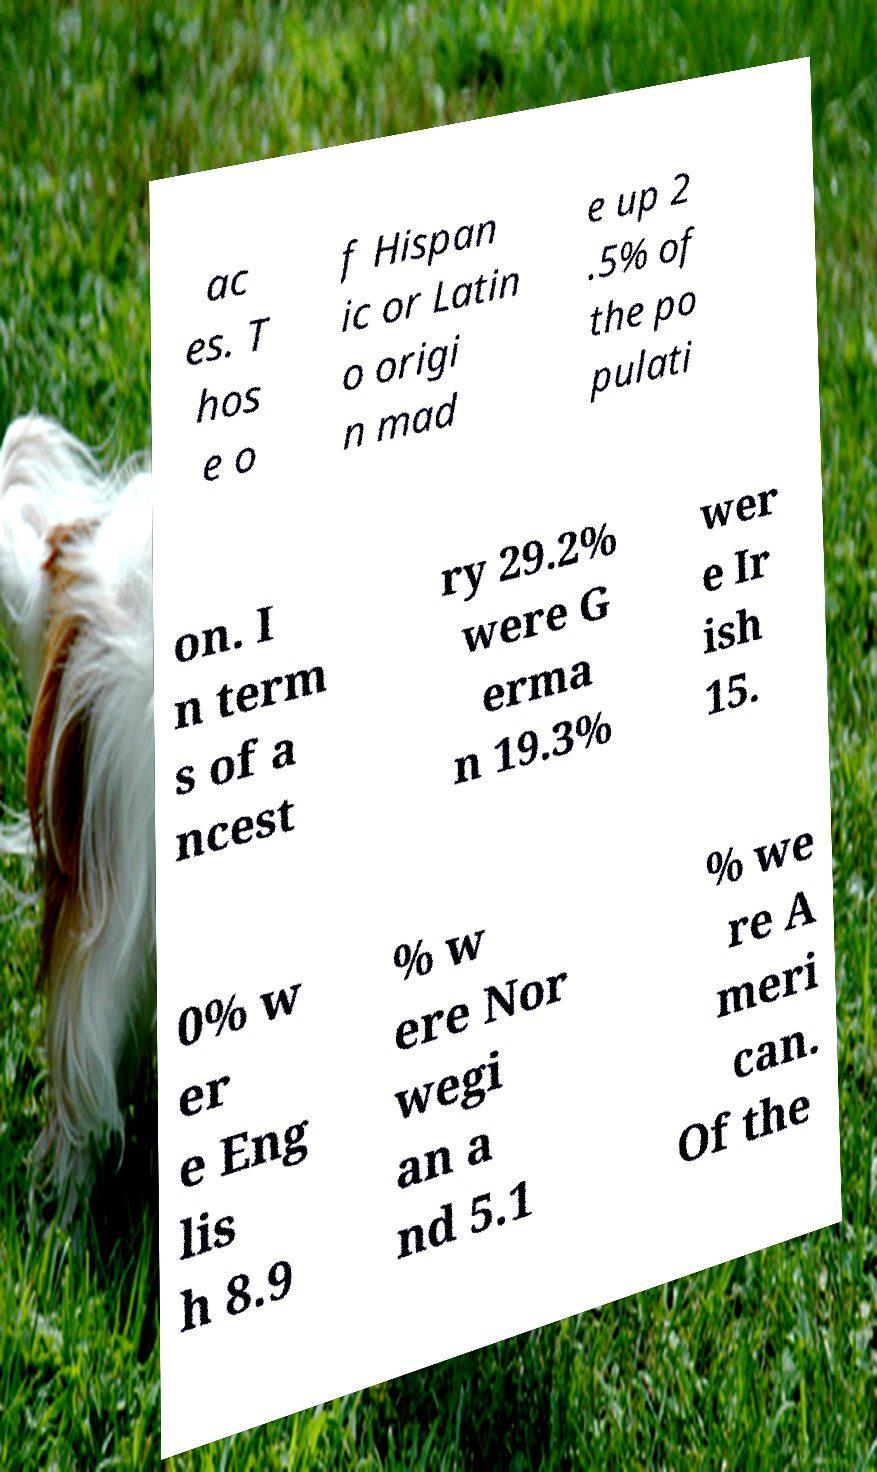Can you accurately transcribe the text from the provided image for me? ac es. T hos e o f Hispan ic or Latin o origi n mad e up 2 .5% of the po pulati on. I n term s of a ncest ry 29.2% were G erma n 19.3% wer e Ir ish 15. 0% w er e Eng lis h 8.9 % w ere Nor wegi an a nd 5.1 % we re A meri can. Of the 